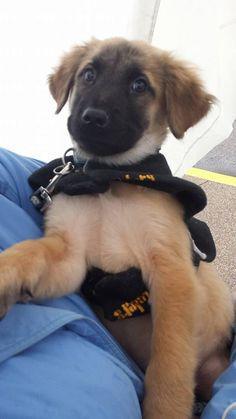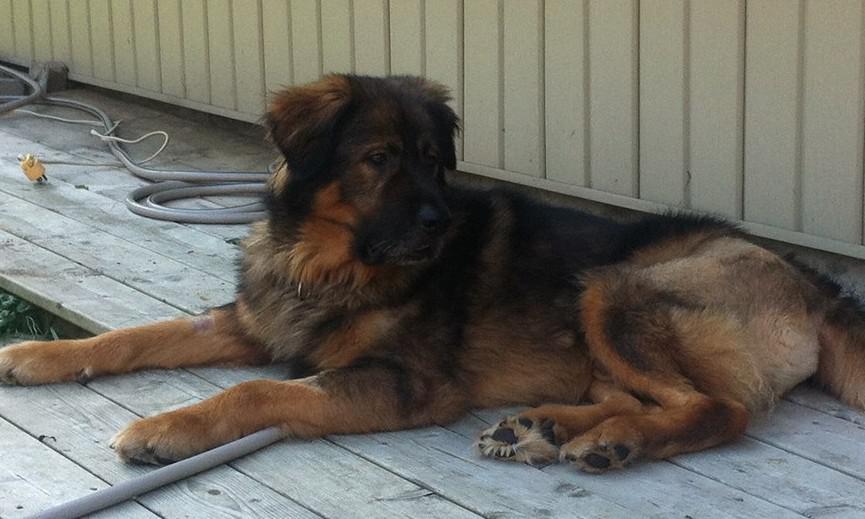The first image is the image on the left, the second image is the image on the right. Examine the images to the left and right. Is the description "In one image a dog is outdoors with its tongue showing." accurate? Answer yes or no. No. 